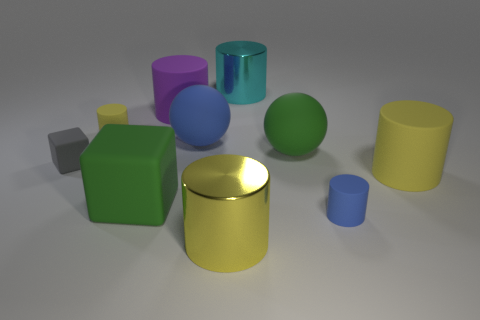Imagine these objects are part of a children's playset. What learning activities could they be used for? These objects could serve as an excellent resource for a variety of educational activities. For instance, they could be used to teach children about colors and shapes, spatial relationships through stacking and arranging, and even basic principles of physics like balance. Moreover, they could facilitate creative play, as children invent scenarios or use them as props in storytelling. 